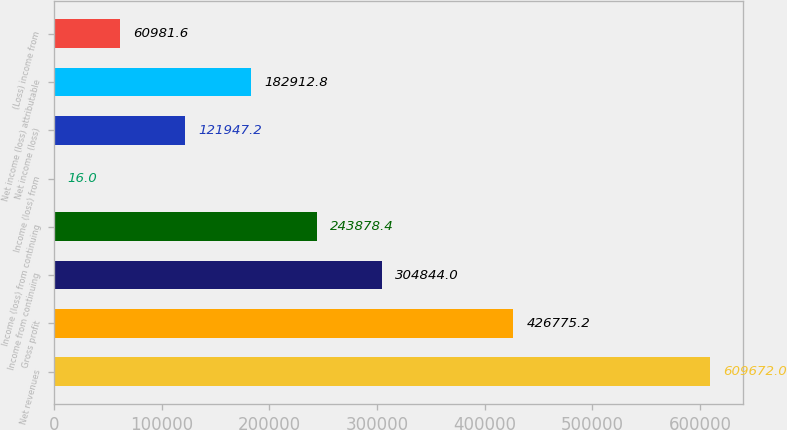Convert chart to OTSL. <chart><loc_0><loc_0><loc_500><loc_500><bar_chart><fcel>Net revenues<fcel>Gross profit<fcel>Income from continuing<fcel>Income (loss) from continuing<fcel>Income (loss) from<fcel>Net income (loss)<fcel>Net income (loss) attributable<fcel>(Loss) income from<nl><fcel>609672<fcel>426775<fcel>304844<fcel>243878<fcel>16<fcel>121947<fcel>182913<fcel>60981.6<nl></chart> 